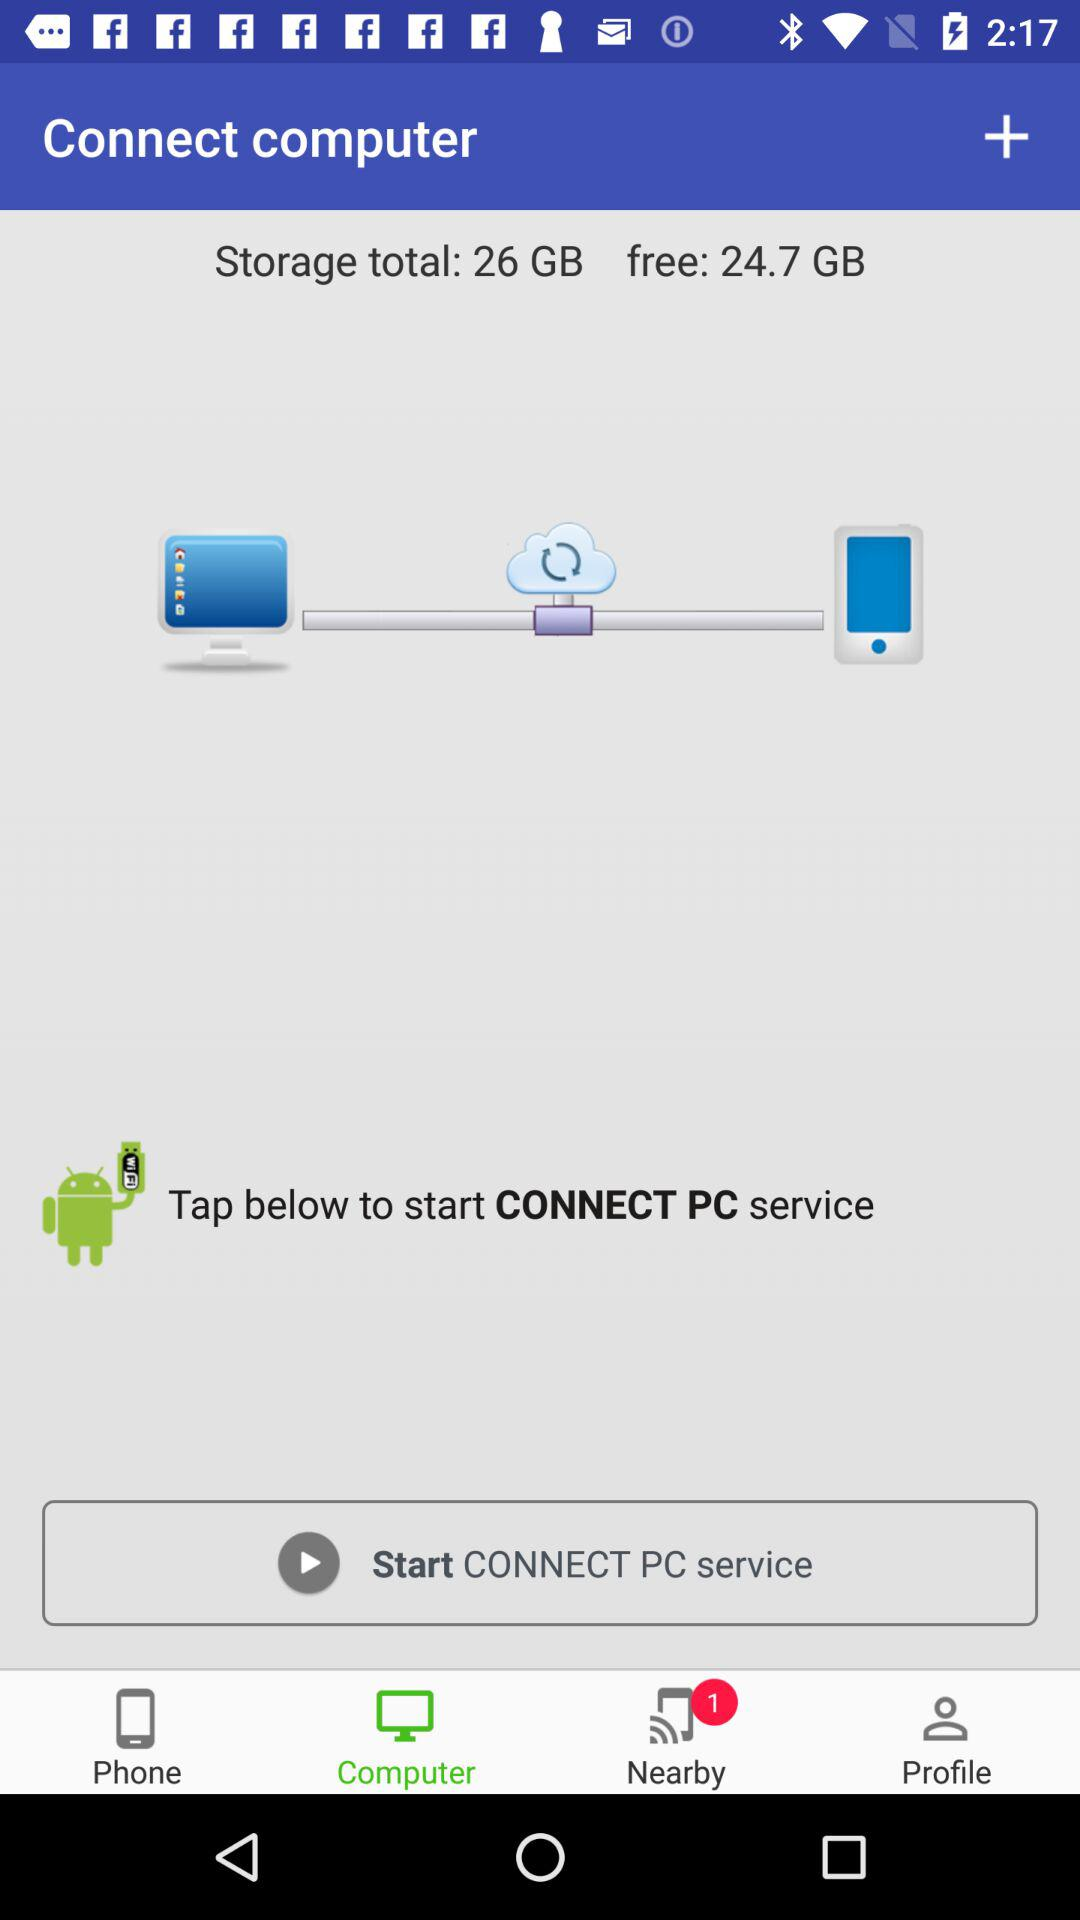How much storage is left?
Answer the question using a single word or phrase. 24.7 GB 